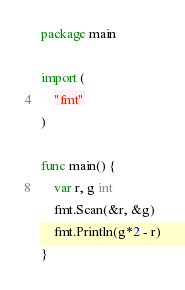Convert code to text. <code><loc_0><loc_0><loc_500><loc_500><_Go_>package main

import (
	"fmt"
)

func main() {
	var r, g int
	fmt.Scan(&r, &g)
	fmt.Println(g*2 - r)
}
</code> 